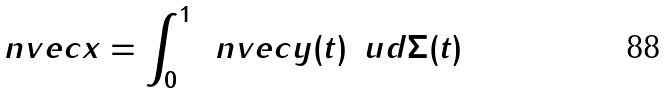Convert formula to latex. <formula><loc_0><loc_0><loc_500><loc_500>\ n v e c { x } = \int _ { 0 } ^ { 1 } \, \ n v e c { y } ( t ) \, \ u d \Sigma ( t )</formula> 